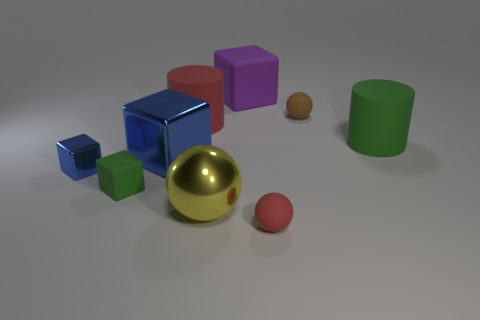Is the color of the tiny rubber ball that is in front of the small brown matte thing the same as the cylinder behind the green rubber cylinder?
Provide a succinct answer. Yes. What size is the rubber cylinder behind the large green thing?
Ensure brevity in your answer.  Large. Is there a large ball made of the same material as the brown thing?
Your answer should be compact. No. Is the color of the object that is right of the tiny brown ball the same as the small rubber cube?
Provide a succinct answer. Yes. Are there an equal number of big green rubber cylinders behind the small green rubber thing and small green matte objects?
Ensure brevity in your answer.  Yes. Are there any big matte cylinders that have the same color as the big ball?
Keep it short and to the point. No. Is the size of the purple matte block the same as the yellow metallic thing?
Offer a terse response. Yes. What is the size of the matte block that is in front of the tiny thing behind the tiny shiny cube?
Your answer should be compact. Small. There is a thing that is both to the left of the red ball and in front of the green cube; how big is it?
Ensure brevity in your answer.  Large. How many yellow objects have the same size as the purple object?
Your answer should be very brief. 1. 